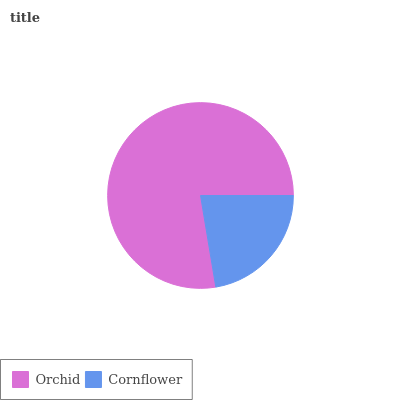Is Cornflower the minimum?
Answer yes or no. Yes. Is Orchid the maximum?
Answer yes or no. Yes. Is Cornflower the maximum?
Answer yes or no. No. Is Orchid greater than Cornflower?
Answer yes or no. Yes. Is Cornflower less than Orchid?
Answer yes or no. Yes. Is Cornflower greater than Orchid?
Answer yes or no. No. Is Orchid less than Cornflower?
Answer yes or no. No. Is Orchid the high median?
Answer yes or no. Yes. Is Cornflower the low median?
Answer yes or no. Yes. Is Cornflower the high median?
Answer yes or no. No. Is Orchid the low median?
Answer yes or no. No. 